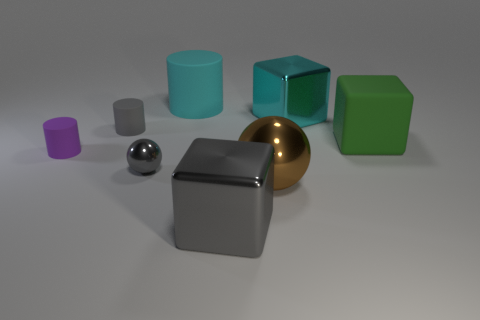Subtract all small purple cylinders. How many cylinders are left? 2 Add 2 big brown metallic balls. How many objects exist? 10 Subtract all gray spheres. How many spheres are left? 1 Subtract all cylinders. How many objects are left? 5 Subtract 3 cubes. How many cubes are left? 0 Subtract all blue spheres. Subtract all yellow cylinders. How many spheres are left? 2 Subtract all blue cylinders. How many gray spheres are left? 1 Subtract all tiny gray metallic spheres. Subtract all green matte objects. How many objects are left? 6 Add 6 tiny purple matte objects. How many tiny purple matte objects are left? 7 Add 4 gray metallic blocks. How many gray metallic blocks exist? 5 